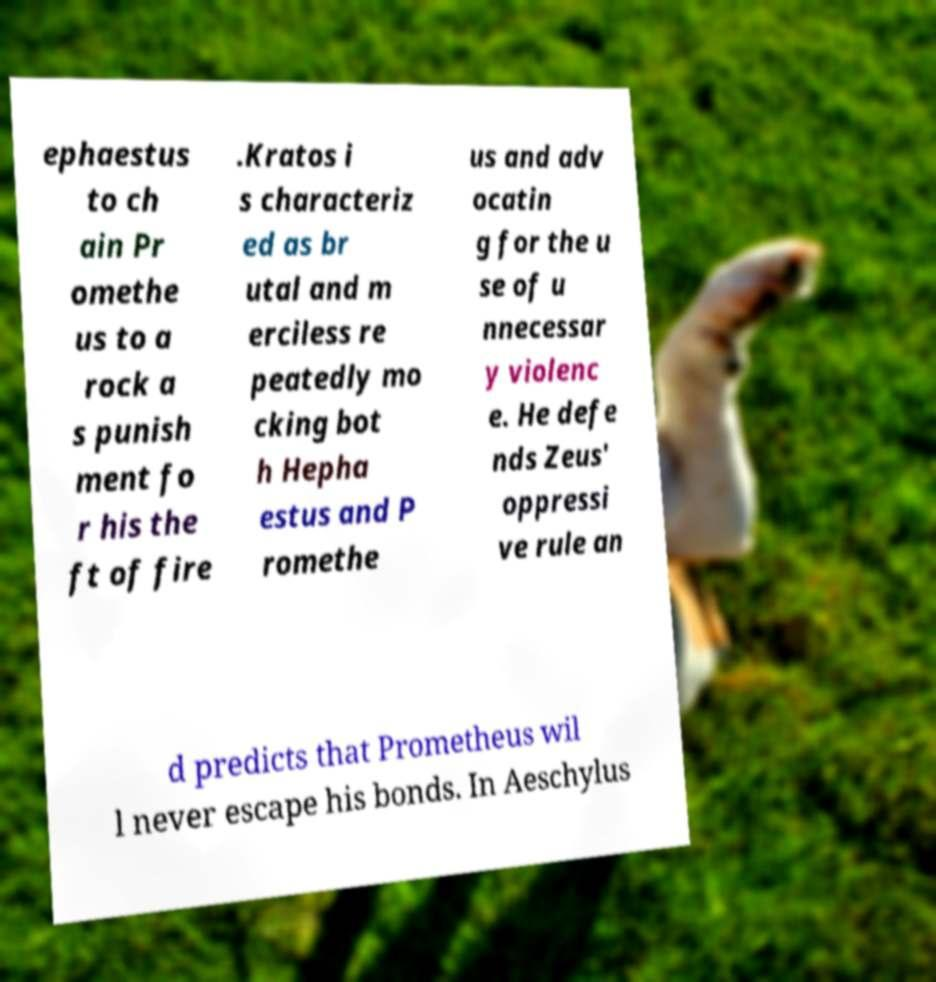I need the written content from this picture converted into text. Can you do that? ephaestus to ch ain Pr omethe us to a rock a s punish ment fo r his the ft of fire .Kratos i s characteriz ed as br utal and m erciless re peatedly mo cking bot h Hepha estus and P romethe us and adv ocatin g for the u se of u nnecessar y violenc e. He defe nds Zeus' oppressi ve rule an d predicts that Prometheus wil l never escape his bonds. In Aeschylus 